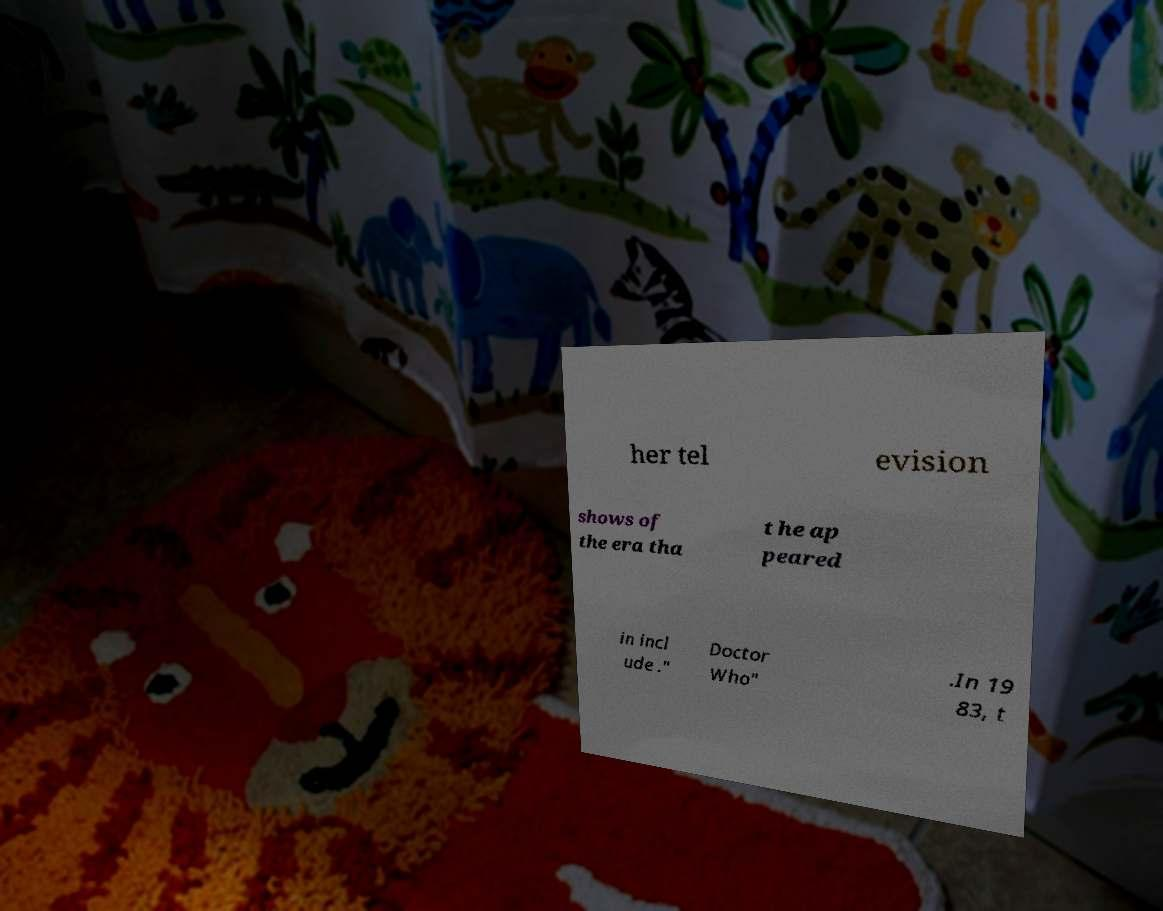Please identify and transcribe the text found in this image. her tel evision shows of the era tha t he ap peared in incl ude ." Doctor Who" .In 19 83, t 